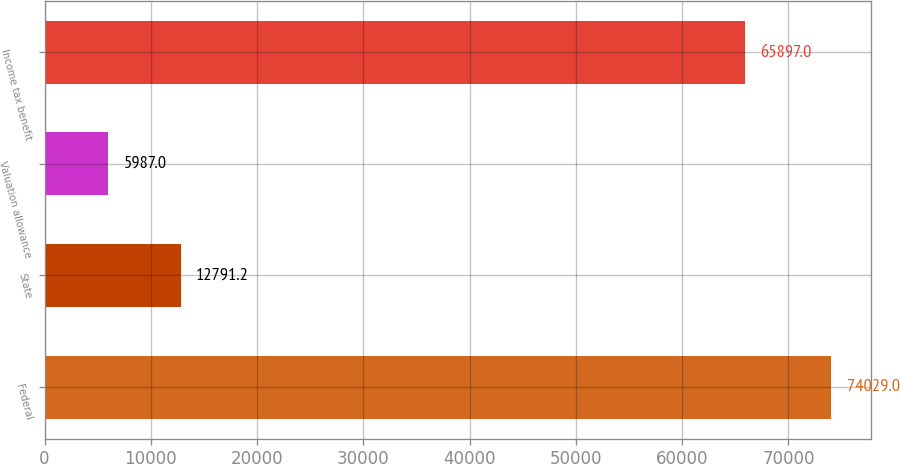<chart> <loc_0><loc_0><loc_500><loc_500><bar_chart><fcel>Federal<fcel>State<fcel>Valuation allowance<fcel>Income tax benefit<nl><fcel>74029<fcel>12791.2<fcel>5987<fcel>65897<nl></chart> 